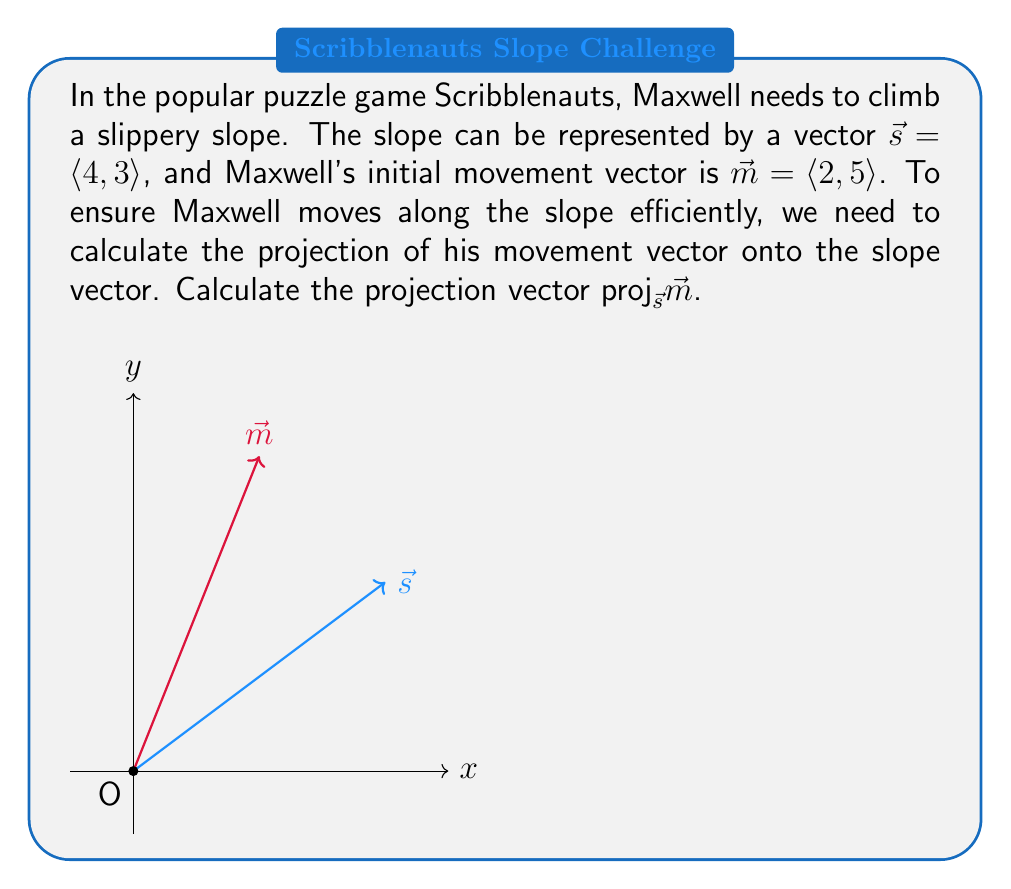Can you answer this question? To calculate the projection of $\vec{m}$ onto $\vec{s}$, we'll use the formula:

$$\text{proj}_{\vec{s}}\vec{m} = \frac{\vec{m} \cdot \vec{s}}{\|\vec{s}\|^2} \vec{s}$$

Step 1: Calculate the dot product $\vec{m} \cdot \vec{s}$
$$\vec{m} \cdot \vec{s} = (2)(4) + (5)(3) = 8 + 15 = 23$$

Step 2: Calculate the magnitude of $\vec{s}$ squared
$$\|\vec{s}\|^2 = 4^2 + 3^2 = 16 + 9 = 25$$

Step 3: Calculate the scalar projection
$$\frac{\vec{m} \cdot \vec{s}}{\|\vec{s}\|^2} = \frac{23}{25}$$

Step 4: Multiply the scalar projection by $\vec{s}$
$$\text{proj}_{\vec{s}}\vec{m} = \frac{23}{25} \langle 4, 3 \rangle = \left\langle \frac{92}{25}, \frac{69}{25} \right\rangle$$

Step 5: Simplify the fraction (optional)
$$\text{proj}_{\vec{s}}\vec{m} = \langle 3.68, 2.76 \rangle$$
Answer: $\langle 3.68, 2.76 \rangle$ or $\left\langle \frac{92}{25}, \frac{69}{25} \right\rangle$ 